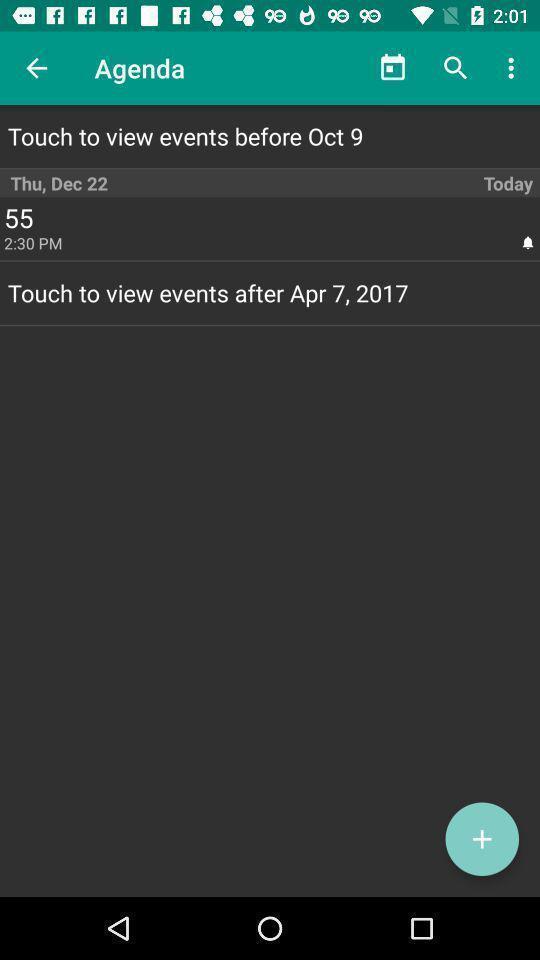Provide a description of this screenshot. Screen displaying the agenda page. 